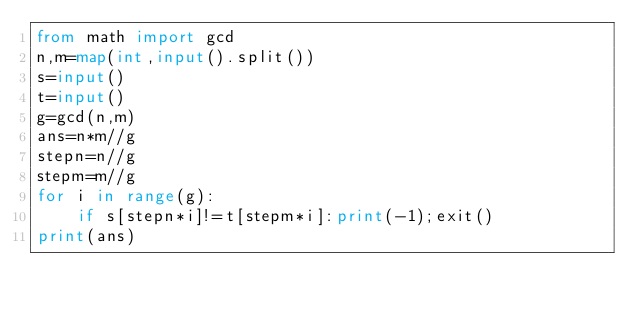<code> <loc_0><loc_0><loc_500><loc_500><_Python_>from math import gcd
n,m=map(int,input().split())
s=input()
t=input()
g=gcd(n,m)
ans=n*m//g
stepn=n//g
stepm=m//g
for i in range(g):
    if s[stepn*i]!=t[stepm*i]:print(-1);exit()
print(ans)</code> 